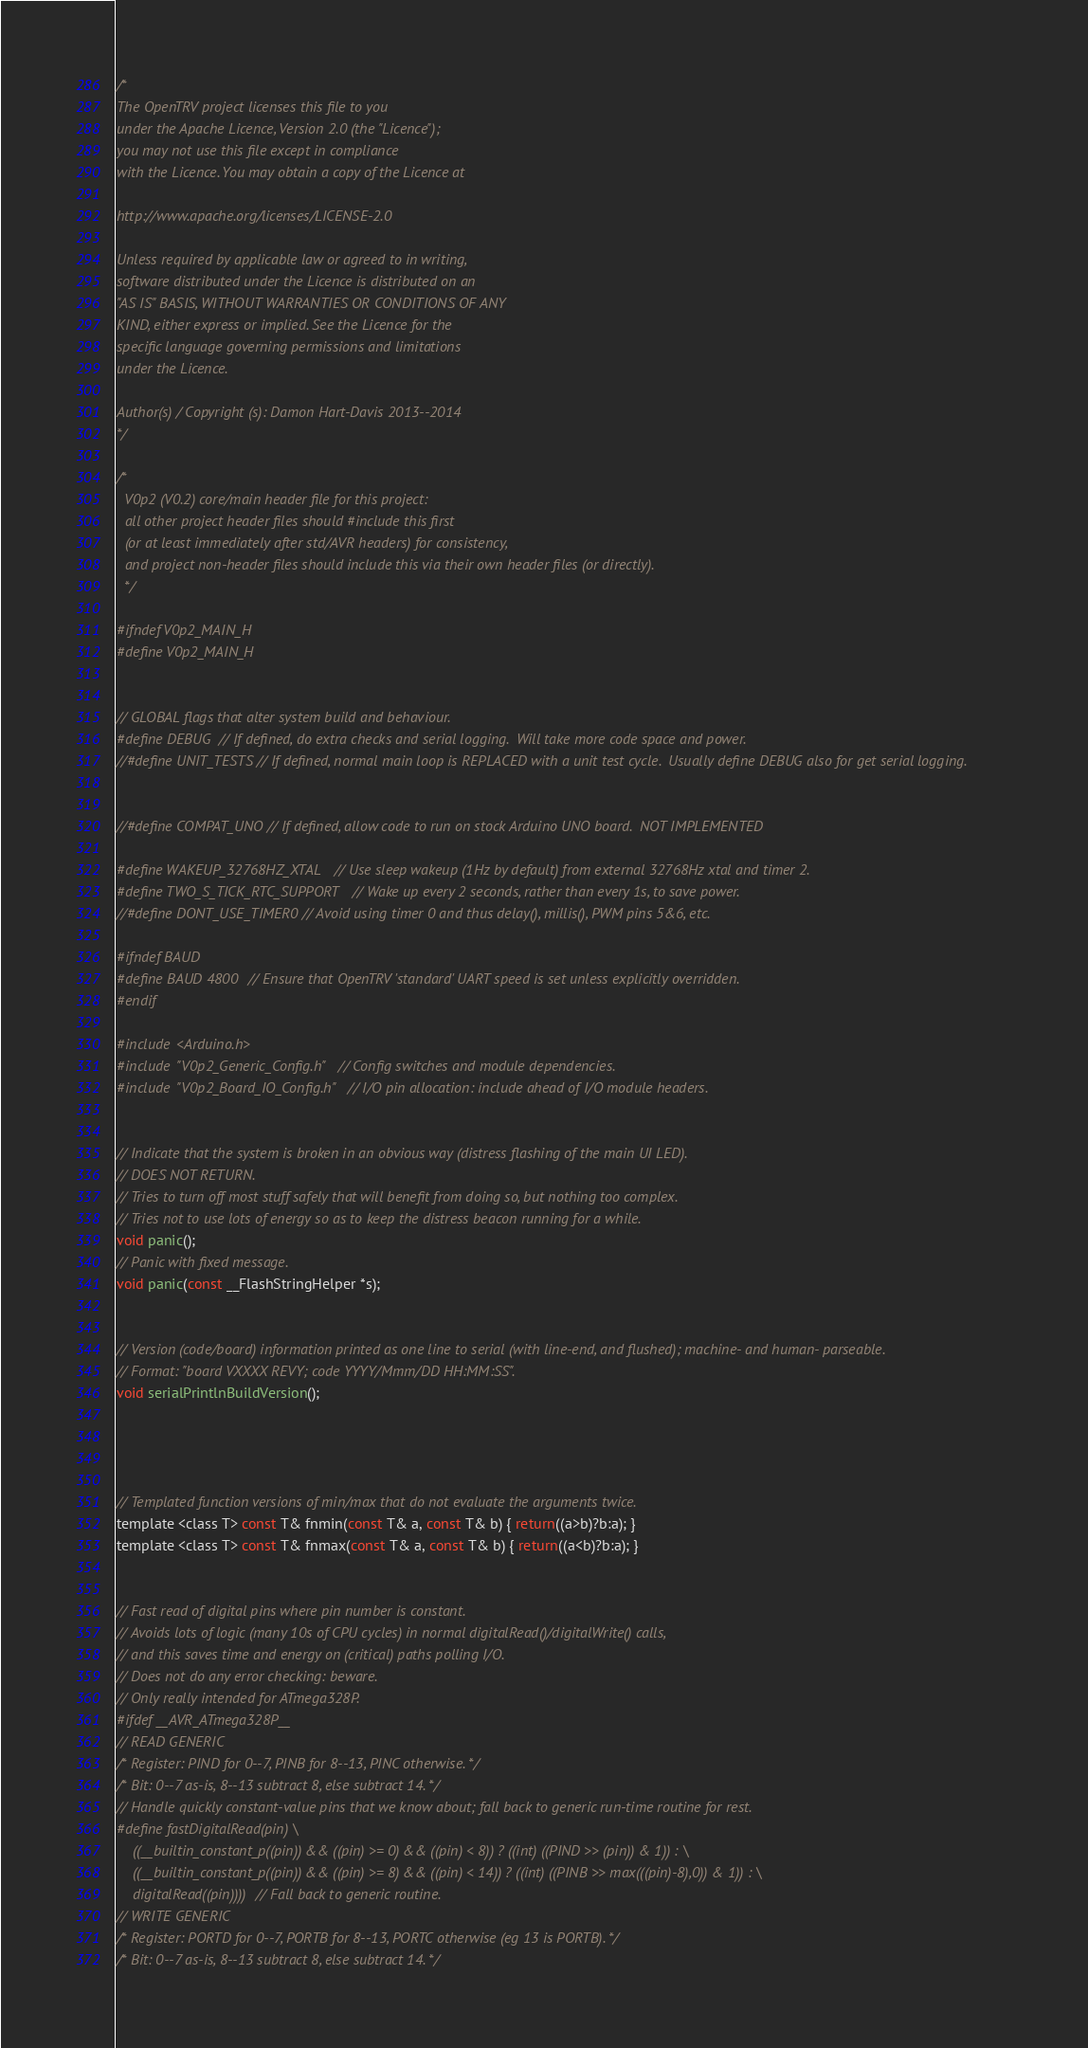Convert code to text. <code><loc_0><loc_0><loc_500><loc_500><_C_>/*
The OpenTRV project licenses this file to you
under the Apache Licence, Version 2.0 (the "Licence");
you may not use this file except in compliance
with the Licence. You may obtain a copy of the Licence at

http://www.apache.org/licenses/LICENSE-2.0

Unless required by applicable law or agreed to in writing,
software distributed under the Licence is distributed on an
"AS IS" BASIS, WITHOUT WARRANTIES OR CONDITIONS OF ANY
KIND, either express or implied. See the Licence for the
specific language governing permissions and limitations
under the Licence.

Author(s) / Copyright (s): Damon Hart-Davis 2013--2014
*/

/*
  V0p2 (V0.2) core/main header file for this project:
  all other project header files should #include this first
  (or at least immediately after std/AVR headers) for consistency,
  and project non-header files should include this via their own header files (or directly).
  */

#ifndef V0p2_MAIN_H
#define V0p2_MAIN_H


// GLOBAL flags that alter system build and behaviour.
#define DEBUG // If defined, do extra checks and serial logging.  Will take more code space and power.
//#define UNIT_TESTS // If defined, normal main loop is REPLACED with a unit test cycle.  Usually define DEBUG also for get serial logging.


//#define COMPAT_UNO // If defined, allow code to run on stock Arduino UNO board.  NOT IMPLEMENTED

#define WAKEUP_32768HZ_XTAL // Use sleep wakeup (1Hz by default) from external 32768Hz xtal and timer 2.
#define TWO_S_TICK_RTC_SUPPORT // Wake up every 2 seconds, rather than every 1s, to save power.
//#define DONT_USE_TIMER0 // Avoid using timer 0 and thus delay(), millis(), PWM pins 5&6, etc.

#ifndef BAUD
#define BAUD 4800 // Ensure that OpenTRV 'standard' UART speed is set unless explicitly overridden.
#endif

#include <Arduino.h>
#include "V0p2_Generic_Config.h" // Config switches and module dependencies.
#include "V0p2_Board_IO_Config.h" // I/O pin allocation: include ahead of I/O module headers.


// Indicate that the system is broken in an obvious way (distress flashing of the main UI LED).
// DOES NOT RETURN.
// Tries to turn off most stuff safely that will benefit from doing so, but nothing too complex.
// Tries not to use lots of energy so as to keep the distress beacon running for a while.
void panic();
// Panic with fixed message.
void panic(const __FlashStringHelper *s);


// Version (code/board) information printed as one line to serial (with line-end, and flushed); machine- and human- parseable.
// Format: "board VXXXX REVY; code YYYY/Mmm/DD HH:MM:SS".
void serialPrintlnBuildVersion();




// Templated function versions of min/max that do not evaluate the arguments twice.
template <class T> const T& fnmin(const T& a, const T& b) { return((a>b)?b:a); }
template <class T> const T& fnmax(const T& a, const T& b) { return((a<b)?b:a); }


// Fast read of digital pins where pin number is constant.
// Avoids lots of logic (many 10s of CPU cycles) in normal digitalRead()/digitalWrite() calls,
// and this saves time and energy on (critical) paths polling I/O.
// Does not do any error checking: beware.
// Only really intended for ATmega328P.
#ifdef __AVR_ATmega328P__
// READ GENERIC
/* Register: PIND for 0--7, PINB for 8--13, PINC otherwise. */
/* Bit: 0--7 as-is, 8--13 subtract 8, else subtract 14. */
// Handle quickly constant-value pins that we know about; fall back to generic run-time routine for rest.
#define fastDigitalRead(pin) \
    ((__builtin_constant_p((pin)) && ((pin) >= 0) && ((pin) < 8)) ? ((int) ((PIND >> (pin)) & 1)) : \
    ((__builtin_constant_p((pin)) && ((pin) >= 8) && ((pin) < 14)) ? ((int) ((PINB >> max(((pin)-8),0)) & 1)) : \
    digitalRead((pin)))) // Fall back to generic routine.    
// WRITE GENERIC
/* Register: PORTD for 0--7, PORTB for 8--13, PORTC otherwise (eg 13 is PORTB). */
/* Bit: 0--7 as-is, 8--13 subtract 8, else subtract 14. */</code> 